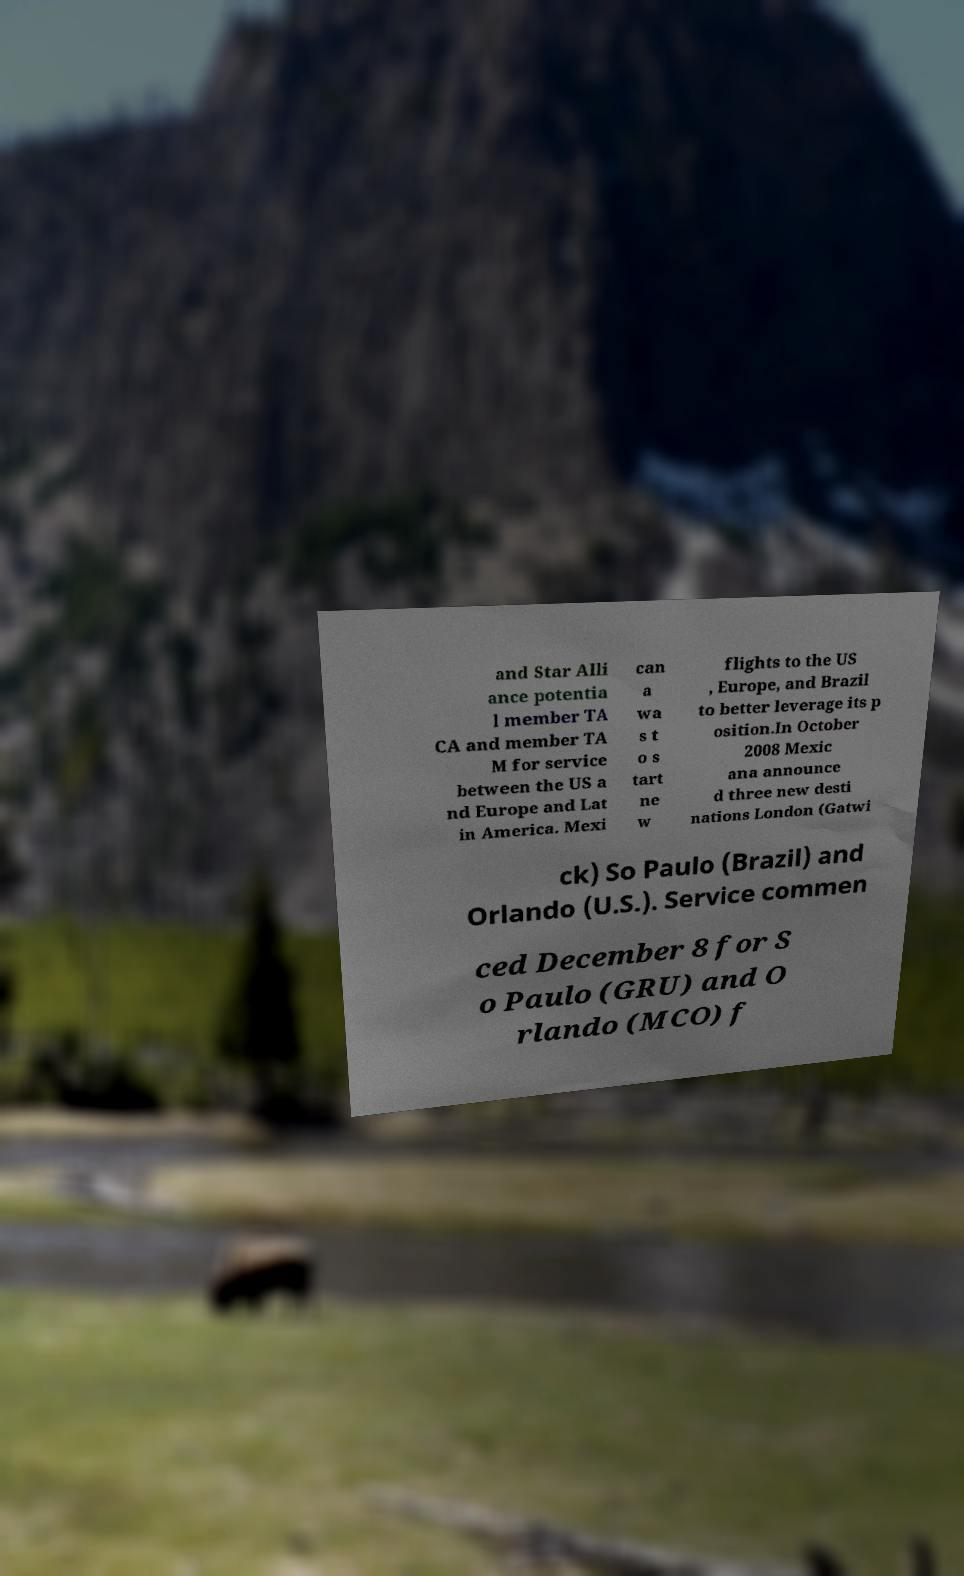Please identify and transcribe the text found in this image. and Star Alli ance potentia l member TA CA and member TA M for service between the US a nd Europe and Lat in America. Mexi can a wa s t o s tart ne w flights to the US , Europe, and Brazil to better leverage its p osition.In October 2008 Mexic ana announce d three new desti nations London (Gatwi ck) So Paulo (Brazil) and Orlando (U.S.). Service commen ced December 8 for S o Paulo (GRU) and O rlando (MCO) f 